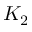<formula> <loc_0><loc_0><loc_500><loc_500>K _ { 2 }</formula> 